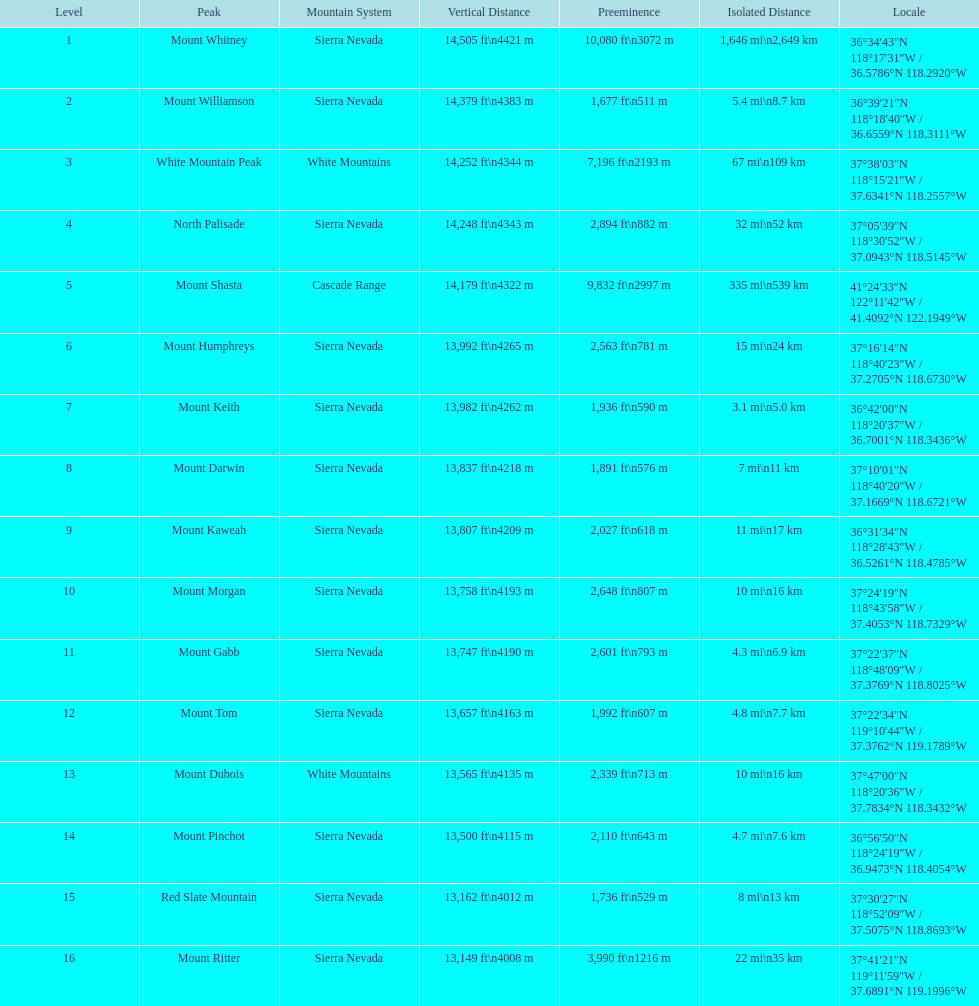Does the crest of mount keith lie above or below the zenith of north palisade? Below. 